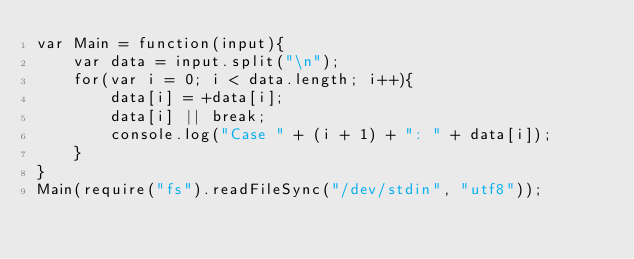<code> <loc_0><loc_0><loc_500><loc_500><_JavaScript_>var Main = function(input){
	var data = input.split("\n");
	for(var i = 0; i < data.length; i++){
		data[i] = +data[i];
		data[i] || break;
		console.log("Case " + (i + 1) + ": " + data[i]);
	}
}
Main(require("fs").readFileSync("/dev/stdin", "utf8"));</code> 